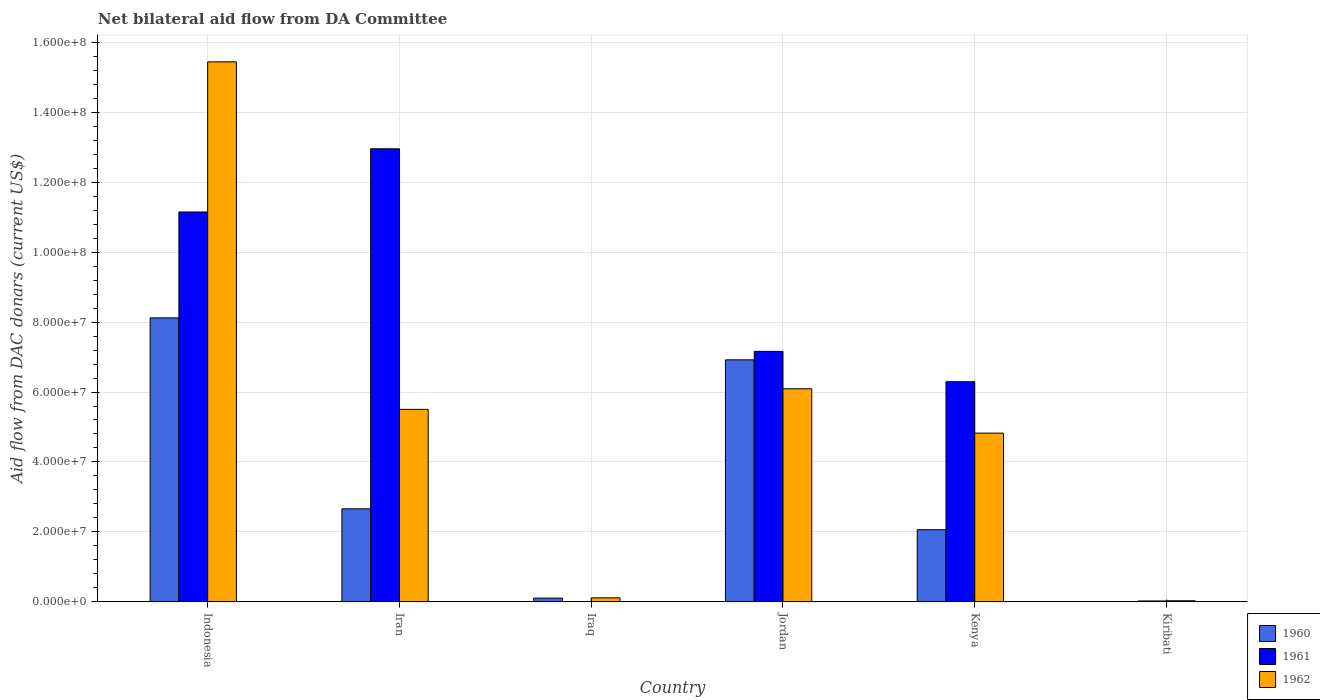How many different coloured bars are there?
Ensure brevity in your answer.  3. How many groups of bars are there?
Offer a very short reply. 6. Are the number of bars on each tick of the X-axis equal?
Keep it short and to the point. Yes. How many bars are there on the 1st tick from the right?
Your answer should be compact. 3. What is the label of the 2nd group of bars from the left?
Provide a short and direct response. Iran. What is the aid flow in in 1961 in Iran?
Make the answer very short. 1.30e+08. Across all countries, what is the maximum aid flow in in 1960?
Offer a terse response. 8.12e+07. In which country was the aid flow in in 1960 minimum?
Your answer should be very brief. Kiribati. What is the total aid flow in in 1960 in the graph?
Make the answer very short. 1.99e+08. What is the difference between the aid flow in in 1962 in Iraq and that in Kenya?
Provide a succinct answer. -4.71e+07. What is the difference between the aid flow in in 1961 in Jordan and the aid flow in in 1962 in Kiribati?
Offer a terse response. 7.13e+07. What is the average aid flow in in 1960 per country?
Provide a short and direct response. 3.31e+07. What is the difference between the aid flow in of/in 1961 and aid flow in of/in 1962 in Indonesia?
Offer a very short reply. -4.29e+07. In how many countries, is the aid flow in in 1962 greater than 16000000 US$?
Provide a short and direct response. 4. What is the ratio of the aid flow in in 1960 in Iran to that in Kiribati?
Provide a succinct answer. 1330.5. What is the difference between the highest and the second highest aid flow in in 1961?
Give a very brief answer. 5.79e+07. What is the difference between the highest and the lowest aid flow in in 1961?
Provide a succinct answer. 1.30e+08. What does the 1st bar from the left in Kenya represents?
Your answer should be compact. 1960. Is it the case that in every country, the sum of the aid flow in in 1962 and aid flow in in 1961 is greater than the aid flow in in 1960?
Your answer should be compact. Yes. How many bars are there?
Your answer should be very brief. 18. Does the graph contain any zero values?
Give a very brief answer. No. Does the graph contain grids?
Ensure brevity in your answer.  Yes. Where does the legend appear in the graph?
Provide a succinct answer. Bottom right. How many legend labels are there?
Your answer should be compact. 3. How are the legend labels stacked?
Provide a succinct answer. Vertical. What is the title of the graph?
Ensure brevity in your answer.  Net bilateral aid flow from DA Committee. Does "1997" appear as one of the legend labels in the graph?
Offer a very short reply. No. What is the label or title of the X-axis?
Your answer should be very brief. Country. What is the label or title of the Y-axis?
Your answer should be compact. Aid flow from DAC donars (current US$). What is the Aid flow from DAC donars (current US$) in 1960 in Indonesia?
Your response must be concise. 8.12e+07. What is the Aid flow from DAC donars (current US$) in 1961 in Indonesia?
Offer a terse response. 1.11e+08. What is the Aid flow from DAC donars (current US$) in 1962 in Indonesia?
Offer a terse response. 1.54e+08. What is the Aid flow from DAC donars (current US$) of 1960 in Iran?
Give a very brief answer. 2.66e+07. What is the Aid flow from DAC donars (current US$) of 1961 in Iran?
Make the answer very short. 1.30e+08. What is the Aid flow from DAC donars (current US$) in 1962 in Iran?
Provide a short and direct response. 5.50e+07. What is the Aid flow from DAC donars (current US$) in 1960 in Iraq?
Your answer should be very brief. 1.08e+06. What is the Aid flow from DAC donars (current US$) of 1962 in Iraq?
Provide a short and direct response. 1.15e+06. What is the Aid flow from DAC donars (current US$) of 1960 in Jordan?
Your response must be concise. 6.92e+07. What is the Aid flow from DAC donars (current US$) of 1961 in Jordan?
Your answer should be very brief. 7.16e+07. What is the Aid flow from DAC donars (current US$) of 1962 in Jordan?
Offer a terse response. 6.09e+07. What is the Aid flow from DAC donars (current US$) in 1960 in Kenya?
Ensure brevity in your answer.  2.06e+07. What is the Aid flow from DAC donars (current US$) of 1961 in Kenya?
Keep it short and to the point. 6.29e+07. What is the Aid flow from DAC donars (current US$) of 1962 in Kenya?
Offer a terse response. 4.82e+07. What is the Aid flow from DAC donars (current US$) of 1961 in Kiribati?
Ensure brevity in your answer.  2.60e+05. Across all countries, what is the maximum Aid flow from DAC donars (current US$) of 1960?
Your response must be concise. 8.12e+07. Across all countries, what is the maximum Aid flow from DAC donars (current US$) of 1961?
Give a very brief answer. 1.30e+08. Across all countries, what is the maximum Aid flow from DAC donars (current US$) in 1962?
Give a very brief answer. 1.54e+08. Across all countries, what is the minimum Aid flow from DAC donars (current US$) of 1960?
Make the answer very short. 2.00e+04. What is the total Aid flow from DAC donars (current US$) in 1960 in the graph?
Provide a succinct answer. 1.99e+08. What is the total Aid flow from DAC donars (current US$) of 1961 in the graph?
Provide a short and direct response. 3.76e+08. What is the total Aid flow from DAC donars (current US$) in 1962 in the graph?
Provide a succinct answer. 3.20e+08. What is the difference between the Aid flow from DAC donars (current US$) of 1960 in Indonesia and that in Iran?
Your answer should be very brief. 5.46e+07. What is the difference between the Aid flow from DAC donars (current US$) of 1961 in Indonesia and that in Iran?
Ensure brevity in your answer.  -1.81e+07. What is the difference between the Aid flow from DAC donars (current US$) of 1962 in Indonesia and that in Iran?
Offer a very short reply. 9.94e+07. What is the difference between the Aid flow from DAC donars (current US$) of 1960 in Indonesia and that in Iraq?
Ensure brevity in your answer.  8.01e+07. What is the difference between the Aid flow from DAC donars (current US$) of 1961 in Indonesia and that in Iraq?
Keep it short and to the point. 1.11e+08. What is the difference between the Aid flow from DAC donars (current US$) in 1962 in Indonesia and that in Iraq?
Keep it short and to the point. 1.53e+08. What is the difference between the Aid flow from DAC donars (current US$) in 1961 in Indonesia and that in Jordan?
Provide a succinct answer. 3.98e+07. What is the difference between the Aid flow from DAC donars (current US$) of 1962 in Indonesia and that in Jordan?
Your answer should be very brief. 9.35e+07. What is the difference between the Aid flow from DAC donars (current US$) of 1960 in Indonesia and that in Kenya?
Keep it short and to the point. 6.06e+07. What is the difference between the Aid flow from DAC donars (current US$) of 1961 in Indonesia and that in Kenya?
Keep it short and to the point. 4.85e+07. What is the difference between the Aid flow from DAC donars (current US$) of 1962 in Indonesia and that in Kenya?
Make the answer very short. 1.06e+08. What is the difference between the Aid flow from DAC donars (current US$) of 1960 in Indonesia and that in Kiribati?
Your answer should be compact. 8.12e+07. What is the difference between the Aid flow from DAC donars (current US$) in 1961 in Indonesia and that in Kiribati?
Keep it short and to the point. 1.11e+08. What is the difference between the Aid flow from DAC donars (current US$) of 1962 in Indonesia and that in Kiribati?
Provide a succinct answer. 1.54e+08. What is the difference between the Aid flow from DAC donars (current US$) of 1960 in Iran and that in Iraq?
Offer a terse response. 2.55e+07. What is the difference between the Aid flow from DAC donars (current US$) of 1961 in Iran and that in Iraq?
Offer a very short reply. 1.30e+08. What is the difference between the Aid flow from DAC donars (current US$) in 1962 in Iran and that in Iraq?
Provide a succinct answer. 5.39e+07. What is the difference between the Aid flow from DAC donars (current US$) of 1960 in Iran and that in Jordan?
Offer a very short reply. -4.26e+07. What is the difference between the Aid flow from DAC donars (current US$) of 1961 in Iran and that in Jordan?
Your answer should be very brief. 5.79e+07. What is the difference between the Aid flow from DAC donars (current US$) of 1962 in Iran and that in Jordan?
Keep it short and to the point. -5.89e+06. What is the difference between the Aid flow from DAC donars (current US$) in 1960 in Iran and that in Kenya?
Make the answer very short. 5.98e+06. What is the difference between the Aid flow from DAC donars (current US$) of 1961 in Iran and that in Kenya?
Provide a short and direct response. 6.66e+07. What is the difference between the Aid flow from DAC donars (current US$) of 1962 in Iran and that in Kenya?
Your answer should be compact. 6.79e+06. What is the difference between the Aid flow from DAC donars (current US$) of 1960 in Iran and that in Kiribati?
Make the answer very short. 2.66e+07. What is the difference between the Aid flow from DAC donars (current US$) in 1961 in Iran and that in Kiribati?
Make the answer very short. 1.29e+08. What is the difference between the Aid flow from DAC donars (current US$) of 1962 in Iran and that in Kiribati?
Provide a short and direct response. 5.47e+07. What is the difference between the Aid flow from DAC donars (current US$) in 1960 in Iraq and that in Jordan?
Make the answer very short. -6.81e+07. What is the difference between the Aid flow from DAC donars (current US$) of 1961 in Iraq and that in Jordan?
Your answer should be very brief. -7.16e+07. What is the difference between the Aid flow from DAC donars (current US$) in 1962 in Iraq and that in Jordan?
Ensure brevity in your answer.  -5.98e+07. What is the difference between the Aid flow from DAC donars (current US$) of 1960 in Iraq and that in Kenya?
Provide a succinct answer. -1.96e+07. What is the difference between the Aid flow from DAC donars (current US$) in 1961 in Iraq and that in Kenya?
Keep it short and to the point. -6.29e+07. What is the difference between the Aid flow from DAC donars (current US$) of 1962 in Iraq and that in Kenya?
Give a very brief answer. -4.71e+07. What is the difference between the Aid flow from DAC donars (current US$) in 1960 in Iraq and that in Kiribati?
Offer a very short reply. 1.06e+06. What is the difference between the Aid flow from DAC donars (current US$) in 1962 in Iraq and that in Kiribati?
Offer a very short reply. 8.30e+05. What is the difference between the Aid flow from DAC donars (current US$) in 1960 in Jordan and that in Kenya?
Make the answer very short. 4.86e+07. What is the difference between the Aid flow from DAC donars (current US$) of 1961 in Jordan and that in Kenya?
Your answer should be compact. 8.68e+06. What is the difference between the Aid flow from DAC donars (current US$) in 1962 in Jordan and that in Kenya?
Provide a short and direct response. 1.27e+07. What is the difference between the Aid flow from DAC donars (current US$) in 1960 in Jordan and that in Kiribati?
Your answer should be compact. 6.92e+07. What is the difference between the Aid flow from DAC donars (current US$) of 1961 in Jordan and that in Kiribati?
Keep it short and to the point. 7.14e+07. What is the difference between the Aid flow from DAC donars (current US$) of 1962 in Jordan and that in Kiribati?
Make the answer very short. 6.06e+07. What is the difference between the Aid flow from DAC donars (current US$) in 1960 in Kenya and that in Kiribati?
Make the answer very short. 2.06e+07. What is the difference between the Aid flow from DAC donars (current US$) of 1961 in Kenya and that in Kiribati?
Your answer should be very brief. 6.27e+07. What is the difference between the Aid flow from DAC donars (current US$) of 1962 in Kenya and that in Kiribati?
Offer a terse response. 4.79e+07. What is the difference between the Aid flow from DAC donars (current US$) in 1960 in Indonesia and the Aid flow from DAC donars (current US$) in 1961 in Iran?
Provide a short and direct response. -4.83e+07. What is the difference between the Aid flow from DAC donars (current US$) of 1960 in Indonesia and the Aid flow from DAC donars (current US$) of 1962 in Iran?
Your answer should be very brief. 2.62e+07. What is the difference between the Aid flow from DAC donars (current US$) of 1961 in Indonesia and the Aid flow from DAC donars (current US$) of 1962 in Iran?
Your answer should be very brief. 5.64e+07. What is the difference between the Aid flow from DAC donars (current US$) of 1960 in Indonesia and the Aid flow from DAC donars (current US$) of 1961 in Iraq?
Offer a terse response. 8.12e+07. What is the difference between the Aid flow from DAC donars (current US$) of 1960 in Indonesia and the Aid flow from DAC donars (current US$) of 1962 in Iraq?
Make the answer very short. 8.00e+07. What is the difference between the Aid flow from DAC donars (current US$) in 1961 in Indonesia and the Aid flow from DAC donars (current US$) in 1962 in Iraq?
Provide a succinct answer. 1.10e+08. What is the difference between the Aid flow from DAC donars (current US$) in 1960 in Indonesia and the Aid flow from DAC donars (current US$) in 1961 in Jordan?
Provide a short and direct response. 9.58e+06. What is the difference between the Aid flow from DAC donars (current US$) in 1960 in Indonesia and the Aid flow from DAC donars (current US$) in 1962 in Jordan?
Keep it short and to the point. 2.03e+07. What is the difference between the Aid flow from DAC donars (current US$) in 1961 in Indonesia and the Aid flow from DAC donars (current US$) in 1962 in Jordan?
Ensure brevity in your answer.  5.05e+07. What is the difference between the Aid flow from DAC donars (current US$) in 1960 in Indonesia and the Aid flow from DAC donars (current US$) in 1961 in Kenya?
Provide a short and direct response. 1.83e+07. What is the difference between the Aid flow from DAC donars (current US$) in 1960 in Indonesia and the Aid flow from DAC donars (current US$) in 1962 in Kenya?
Provide a short and direct response. 3.30e+07. What is the difference between the Aid flow from DAC donars (current US$) in 1961 in Indonesia and the Aid flow from DAC donars (current US$) in 1962 in Kenya?
Offer a very short reply. 6.32e+07. What is the difference between the Aid flow from DAC donars (current US$) in 1960 in Indonesia and the Aid flow from DAC donars (current US$) in 1961 in Kiribati?
Ensure brevity in your answer.  8.09e+07. What is the difference between the Aid flow from DAC donars (current US$) of 1960 in Indonesia and the Aid flow from DAC donars (current US$) of 1962 in Kiribati?
Offer a terse response. 8.09e+07. What is the difference between the Aid flow from DAC donars (current US$) of 1961 in Indonesia and the Aid flow from DAC donars (current US$) of 1962 in Kiribati?
Give a very brief answer. 1.11e+08. What is the difference between the Aid flow from DAC donars (current US$) in 1960 in Iran and the Aid flow from DAC donars (current US$) in 1961 in Iraq?
Ensure brevity in your answer.  2.66e+07. What is the difference between the Aid flow from DAC donars (current US$) of 1960 in Iran and the Aid flow from DAC donars (current US$) of 1962 in Iraq?
Provide a succinct answer. 2.55e+07. What is the difference between the Aid flow from DAC donars (current US$) in 1961 in Iran and the Aid flow from DAC donars (current US$) in 1962 in Iraq?
Keep it short and to the point. 1.28e+08. What is the difference between the Aid flow from DAC donars (current US$) of 1960 in Iran and the Aid flow from DAC donars (current US$) of 1961 in Jordan?
Keep it short and to the point. -4.50e+07. What is the difference between the Aid flow from DAC donars (current US$) of 1960 in Iran and the Aid flow from DAC donars (current US$) of 1962 in Jordan?
Offer a very short reply. -3.43e+07. What is the difference between the Aid flow from DAC donars (current US$) of 1961 in Iran and the Aid flow from DAC donars (current US$) of 1962 in Jordan?
Make the answer very short. 6.86e+07. What is the difference between the Aid flow from DAC donars (current US$) in 1960 in Iran and the Aid flow from DAC donars (current US$) in 1961 in Kenya?
Make the answer very short. -3.63e+07. What is the difference between the Aid flow from DAC donars (current US$) in 1960 in Iran and the Aid flow from DAC donars (current US$) in 1962 in Kenya?
Keep it short and to the point. -2.16e+07. What is the difference between the Aid flow from DAC donars (current US$) in 1961 in Iran and the Aid flow from DAC donars (current US$) in 1962 in Kenya?
Ensure brevity in your answer.  8.13e+07. What is the difference between the Aid flow from DAC donars (current US$) in 1960 in Iran and the Aid flow from DAC donars (current US$) in 1961 in Kiribati?
Keep it short and to the point. 2.64e+07. What is the difference between the Aid flow from DAC donars (current US$) of 1960 in Iran and the Aid flow from DAC donars (current US$) of 1962 in Kiribati?
Your answer should be very brief. 2.63e+07. What is the difference between the Aid flow from DAC donars (current US$) of 1961 in Iran and the Aid flow from DAC donars (current US$) of 1962 in Kiribati?
Ensure brevity in your answer.  1.29e+08. What is the difference between the Aid flow from DAC donars (current US$) of 1960 in Iraq and the Aid flow from DAC donars (current US$) of 1961 in Jordan?
Your answer should be compact. -7.05e+07. What is the difference between the Aid flow from DAC donars (current US$) in 1960 in Iraq and the Aid flow from DAC donars (current US$) in 1962 in Jordan?
Your answer should be very brief. -5.98e+07. What is the difference between the Aid flow from DAC donars (current US$) of 1961 in Iraq and the Aid flow from DAC donars (current US$) of 1962 in Jordan?
Provide a succinct answer. -6.09e+07. What is the difference between the Aid flow from DAC donars (current US$) of 1960 in Iraq and the Aid flow from DAC donars (current US$) of 1961 in Kenya?
Give a very brief answer. -6.19e+07. What is the difference between the Aid flow from DAC donars (current US$) of 1960 in Iraq and the Aid flow from DAC donars (current US$) of 1962 in Kenya?
Keep it short and to the point. -4.72e+07. What is the difference between the Aid flow from DAC donars (current US$) in 1961 in Iraq and the Aid flow from DAC donars (current US$) in 1962 in Kenya?
Offer a terse response. -4.82e+07. What is the difference between the Aid flow from DAC donars (current US$) in 1960 in Iraq and the Aid flow from DAC donars (current US$) in 1961 in Kiribati?
Offer a terse response. 8.20e+05. What is the difference between the Aid flow from DAC donars (current US$) in 1960 in Iraq and the Aid flow from DAC donars (current US$) in 1962 in Kiribati?
Offer a terse response. 7.60e+05. What is the difference between the Aid flow from DAC donars (current US$) of 1960 in Jordan and the Aid flow from DAC donars (current US$) of 1961 in Kenya?
Make the answer very short. 6.26e+06. What is the difference between the Aid flow from DAC donars (current US$) in 1960 in Jordan and the Aid flow from DAC donars (current US$) in 1962 in Kenya?
Offer a very short reply. 2.10e+07. What is the difference between the Aid flow from DAC donars (current US$) in 1961 in Jordan and the Aid flow from DAC donars (current US$) in 1962 in Kenya?
Your answer should be compact. 2.34e+07. What is the difference between the Aid flow from DAC donars (current US$) of 1960 in Jordan and the Aid flow from DAC donars (current US$) of 1961 in Kiribati?
Provide a succinct answer. 6.89e+07. What is the difference between the Aid flow from DAC donars (current US$) of 1960 in Jordan and the Aid flow from DAC donars (current US$) of 1962 in Kiribati?
Your answer should be compact. 6.89e+07. What is the difference between the Aid flow from DAC donars (current US$) in 1961 in Jordan and the Aid flow from DAC donars (current US$) in 1962 in Kiribati?
Make the answer very short. 7.13e+07. What is the difference between the Aid flow from DAC donars (current US$) in 1960 in Kenya and the Aid flow from DAC donars (current US$) in 1961 in Kiribati?
Your answer should be compact. 2.04e+07. What is the difference between the Aid flow from DAC donars (current US$) of 1960 in Kenya and the Aid flow from DAC donars (current US$) of 1962 in Kiribati?
Offer a very short reply. 2.03e+07. What is the difference between the Aid flow from DAC donars (current US$) in 1961 in Kenya and the Aid flow from DAC donars (current US$) in 1962 in Kiribati?
Make the answer very short. 6.26e+07. What is the average Aid flow from DAC donars (current US$) in 1960 per country?
Keep it short and to the point. 3.31e+07. What is the average Aid flow from DAC donars (current US$) of 1961 per country?
Provide a succinct answer. 6.26e+07. What is the average Aid flow from DAC donars (current US$) of 1962 per country?
Provide a succinct answer. 5.33e+07. What is the difference between the Aid flow from DAC donars (current US$) in 1960 and Aid flow from DAC donars (current US$) in 1961 in Indonesia?
Provide a short and direct response. -3.03e+07. What is the difference between the Aid flow from DAC donars (current US$) of 1960 and Aid flow from DAC donars (current US$) of 1962 in Indonesia?
Offer a very short reply. -7.32e+07. What is the difference between the Aid flow from DAC donars (current US$) of 1961 and Aid flow from DAC donars (current US$) of 1962 in Indonesia?
Offer a terse response. -4.29e+07. What is the difference between the Aid flow from DAC donars (current US$) in 1960 and Aid flow from DAC donars (current US$) in 1961 in Iran?
Your answer should be very brief. -1.03e+08. What is the difference between the Aid flow from DAC donars (current US$) of 1960 and Aid flow from DAC donars (current US$) of 1962 in Iran?
Give a very brief answer. -2.84e+07. What is the difference between the Aid flow from DAC donars (current US$) of 1961 and Aid flow from DAC donars (current US$) of 1962 in Iran?
Ensure brevity in your answer.  7.45e+07. What is the difference between the Aid flow from DAC donars (current US$) of 1960 and Aid flow from DAC donars (current US$) of 1961 in Iraq?
Offer a very short reply. 1.06e+06. What is the difference between the Aid flow from DAC donars (current US$) of 1961 and Aid flow from DAC donars (current US$) of 1962 in Iraq?
Your answer should be compact. -1.13e+06. What is the difference between the Aid flow from DAC donars (current US$) of 1960 and Aid flow from DAC donars (current US$) of 1961 in Jordan?
Make the answer very short. -2.42e+06. What is the difference between the Aid flow from DAC donars (current US$) in 1960 and Aid flow from DAC donars (current US$) in 1962 in Jordan?
Your response must be concise. 8.27e+06. What is the difference between the Aid flow from DAC donars (current US$) in 1961 and Aid flow from DAC donars (current US$) in 1962 in Jordan?
Give a very brief answer. 1.07e+07. What is the difference between the Aid flow from DAC donars (current US$) in 1960 and Aid flow from DAC donars (current US$) in 1961 in Kenya?
Make the answer very short. -4.23e+07. What is the difference between the Aid flow from DAC donars (current US$) of 1960 and Aid flow from DAC donars (current US$) of 1962 in Kenya?
Make the answer very short. -2.76e+07. What is the difference between the Aid flow from DAC donars (current US$) of 1961 and Aid flow from DAC donars (current US$) of 1962 in Kenya?
Your answer should be compact. 1.47e+07. What is the difference between the Aid flow from DAC donars (current US$) in 1960 and Aid flow from DAC donars (current US$) in 1962 in Kiribati?
Provide a short and direct response. -3.00e+05. What is the ratio of the Aid flow from DAC donars (current US$) in 1960 in Indonesia to that in Iran?
Your response must be concise. 3.05. What is the ratio of the Aid flow from DAC donars (current US$) in 1961 in Indonesia to that in Iran?
Provide a short and direct response. 0.86. What is the ratio of the Aid flow from DAC donars (current US$) of 1962 in Indonesia to that in Iran?
Ensure brevity in your answer.  2.81. What is the ratio of the Aid flow from DAC donars (current US$) in 1960 in Indonesia to that in Iraq?
Your answer should be compact. 75.19. What is the ratio of the Aid flow from DAC donars (current US$) of 1961 in Indonesia to that in Iraq?
Offer a terse response. 5573.5. What is the ratio of the Aid flow from DAC donars (current US$) in 1962 in Indonesia to that in Iraq?
Provide a succinct answer. 134.25. What is the ratio of the Aid flow from DAC donars (current US$) in 1960 in Indonesia to that in Jordan?
Your response must be concise. 1.17. What is the ratio of the Aid flow from DAC donars (current US$) in 1961 in Indonesia to that in Jordan?
Your answer should be very brief. 1.56. What is the ratio of the Aid flow from DAC donars (current US$) in 1962 in Indonesia to that in Jordan?
Provide a short and direct response. 2.53. What is the ratio of the Aid flow from DAC donars (current US$) in 1960 in Indonesia to that in Kenya?
Give a very brief answer. 3.94. What is the ratio of the Aid flow from DAC donars (current US$) of 1961 in Indonesia to that in Kenya?
Give a very brief answer. 1.77. What is the ratio of the Aid flow from DAC donars (current US$) of 1962 in Indonesia to that in Kenya?
Provide a short and direct response. 3.2. What is the ratio of the Aid flow from DAC donars (current US$) in 1960 in Indonesia to that in Kiribati?
Provide a succinct answer. 4060. What is the ratio of the Aid flow from DAC donars (current US$) of 1961 in Indonesia to that in Kiribati?
Your answer should be very brief. 428.73. What is the ratio of the Aid flow from DAC donars (current US$) of 1962 in Indonesia to that in Kiribati?
Your response must be concise. 482.47. What is the ratio of the Aid flow from DAC donars (current US$) in 1960 in Iran to that in Iraq?
Make the answer very short. 24.64. What is the ratio of the Aid flow from DAC donars (current US$) of 1961 in Iran to that in Iraq?
Offer a very short reply. 6477. What is the ratio of the Aid flow from DAC donars (current US$) in 1962 in Iran to that in Iraq?
Offer a very short reply. 47.86. What is the ratio of the Aid flow from DAC donars (current US$) of 1960 in Iran to that in Jordan?
Ensure brevity in your answer.  0.38. What is the ratio of the Aid flow from DAC donars (current US$) of 1961 in Iran to that in Jordan?
Provide a succinct answer. 1.81. What is the ratio of the Aid flow from DAC donars (current US$) in 1962 in Iran to that in Jordan?
Your response must be concise. 0.9. What is the ratio of the Aid flow from DAC donars (current US$) of 1960 in Iran to that in Kenya?
Provide a short and direct response. 1.29. What is the ratio of the Aid flow from DAC donars (current US$) in 1961 in Iran to that in Kenya?
Provide a short and direct response. 2.06. What is the ratio of the Aid flow from DAC donars (current US$) of 1962 in Iran to that in Kenya?
Offer a terse response. 1.14. What is the ratio of the Aid flow from DAC donars (current US$) in 1960 in Iran to that in Kiribati?
Ensure brevity in your answer.  1330.5. What is the ratio of the Aid flow from DAC donars (current US$) of 1961 in Iran to that in Kiribati?
Your answer should be very brief. 498.23. What is the ratio of the Aid flow from DAC donars (current US$) in 1962 in Iran to that in Kiribati?
Ensure brevity in your answer.  172. What is the ratio of the Aid flow from DAC donars (current US$) in 1960 in Iraq to that in Jordan?
Your response must be concise. 0.02. What is the ratio of the Aid flow from DAC donars (current US$) in 1961 in Iraq to that in Jordan?
Offer a very short reply. 0. What is the ratio of the Aid flow from DAC donars (current US$) in 1962 in Iraq to that in Jordan?
Make the answer very short. 0.02. What is the ratio of the Aid flow from DAC donars (current US$) of 1960 in Iraq to that in Kenya?
Your answer should be compact. 0.05. What is the ratio of the Aid flow from DAC donars (current US$) of 1962 in Iraq to that in Kenya?
Make the answer very short. 0.02. What is the ratio of the Aid flow from DAC donars (current US$) in 1961 in Iraq to that in Kiribati?
Offer a very short reply. 0.08. What is the ratio of the Aid flow from DAC donars (current US$) in 1962 in Iraq to that in Kiribati?
Offer a terse response. 3.59. What is the ratio of the Aid flow from DAC donars (current US$) of 1960 in Jordan to that in Kenya?
Give a very brief answer. 3.35. What is the ratio of the Aid flow from DAC donars (current US$) in 1961 in Jordan to that in Kenya?
Offer a terse response. 1.14. What is the ratio of the Aid flow from DAC donars (current US$) of 1962 in Jordan to that in Kenya?
Your answer should be very brief. 1.26. What is the ratio of the Aid flow from DAC donars (current US$) in 1960 in Jordan to that in Kiribati?
Provide a succinct answer. 3460. What is the ratio of the Aid flow from DAC donars (current US$) of 1961 in Jordan to that in Kiribati?
Give a very brief answer. 275.46. What is the ratio of the Aid flow from DAC donars (current US$) in 1962 in Jordan to that in Kiribati?
Your answer should be very brief. 190.41. What is the ratio of the Aid flow from DAC donars (current US$) in 1960 in Kenya to that in Kiribati?
Provide a succinct answer. 1031.5. What is the ratio of the Aid flow from DAC donars (current US$) of 1961 in Kenya to that in Kiribati?
Offer a very short reply. 242.08. What is the ratio of the Aid flow from DAC donars (current US$) of 1962 in Kenya to that in Kiribati?
Keep it short and to the point. 150.78. What is the difference between the highest and the second highest Aid flow from DAC donars (current US$) in 1960?
Your answer should be very brief. 1.20e+07. What is the difference between the highest and the second highest Aid flow from DAC donars (current US$) of 1961?
Your response must be concise. 1.81e+07. What is the difference between the highest and the second highest Aid flow from DAC donars (current US$) in 1962?
Keep it short and to the point. 9.35e+07. What is the difference between the highest and the lowest Aid flow from DAC donars (current US$) in 1960?
Offer a terse response. 8.12e+07. What is the difference between the highest and the lowest Aid flow from DAC donars (current US$) in 1961?
Your answer should be very brief. 1.30e+08. What is the difference between the highest and the lowest Aid flow from DAC donars (current US$) in 1962?
Keep it short and to the point. 1.54e+08. 